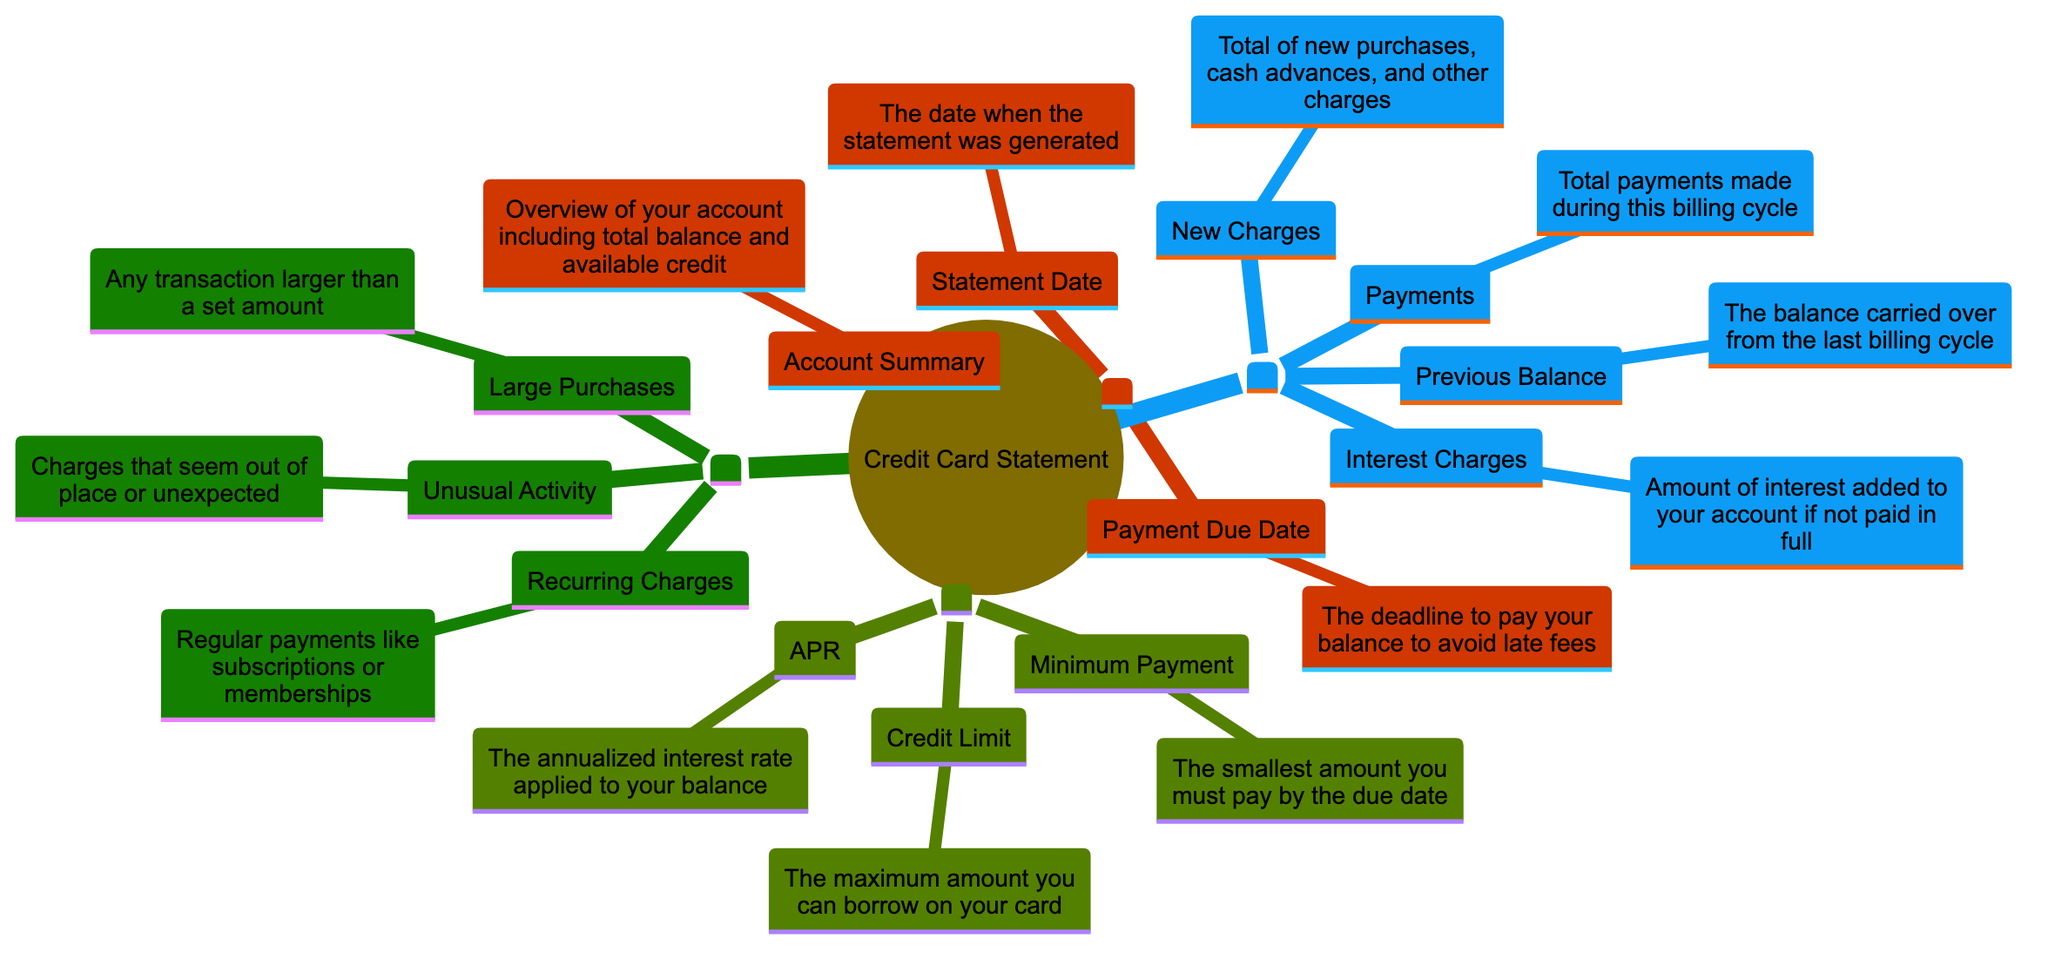What is the statement date? The statement date is the top node under the "Identifying Key Sections" that specifies when the statement was generated. It is a crucial part of the statement, usually shown like the others in a distinct format, indicating the actual date.
Answer: The date when the statement was generated What is the minimum payment? The minimum payment is found under the "Key Definitions" section, defining the smallest amount you must pay by the due date. This term helps users understand their payment obligations.
Answer: The smallest amount you must pay by the due date How many key sections are there in the diagram? By observing the main branches in the diagram, you can count four distinct sections: "Identifying Key Sections," "Understanding Charges," "Key Definitions," and "Highlighting Important Charges." This structural count helps viewers navigate easily.
Answer: Four What defines a recurring charge? A recurring charge is explained under the "Highlighting Important Charges" section, specifying that these are regular payments like subscriptions or memberships. It indicates a predictable expense that appears every billing cycle.
Answer: Regular payments like subscriptions or memberships What section describes the new charges? The new charges are described in the "Understanding Charges" section, highlighting its significance for users to know the total of new purchases, cash advances, and other charges during the billing cycle. This is essential for expense tracking.
Answer: Total of new purchases, cash advances, and other charges If a charge seems out of place, which category does it belong to? An unusual activity charge is marked under the "Highlighting Important Charges" section, indicating transactions that appear abnormal or unexpected. This category serves as a warning for potential fraud or errors.
Answer: Charges that seem out of place or unexpected What does APR stand for? APR is found under the "Key Definitions" section, which defines it as the annualized interest rate applied to your balance. This financial term helps consumers understand the cost of borrowing on their credit cards.
Answer: The annualized interest rate applied to your balance How many different types of charges are highlighted in the diagram? There are three distinct types of charges highlighted within the "Highlighting Important Charges" section: large purchases, recurring charges, and unusual activity. This classification aids users in monitoring their expenses effectively.
Answer: Three 